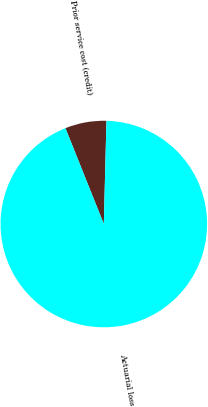Convert chart. <chart><loc_0><loc_0><loc_500><loc_500><pie_chart><fcel>Prior service cost (credit)<fcel>Actuarial loss<nl><fcel>6.47%<fcel>93.53%<nl></chart> 